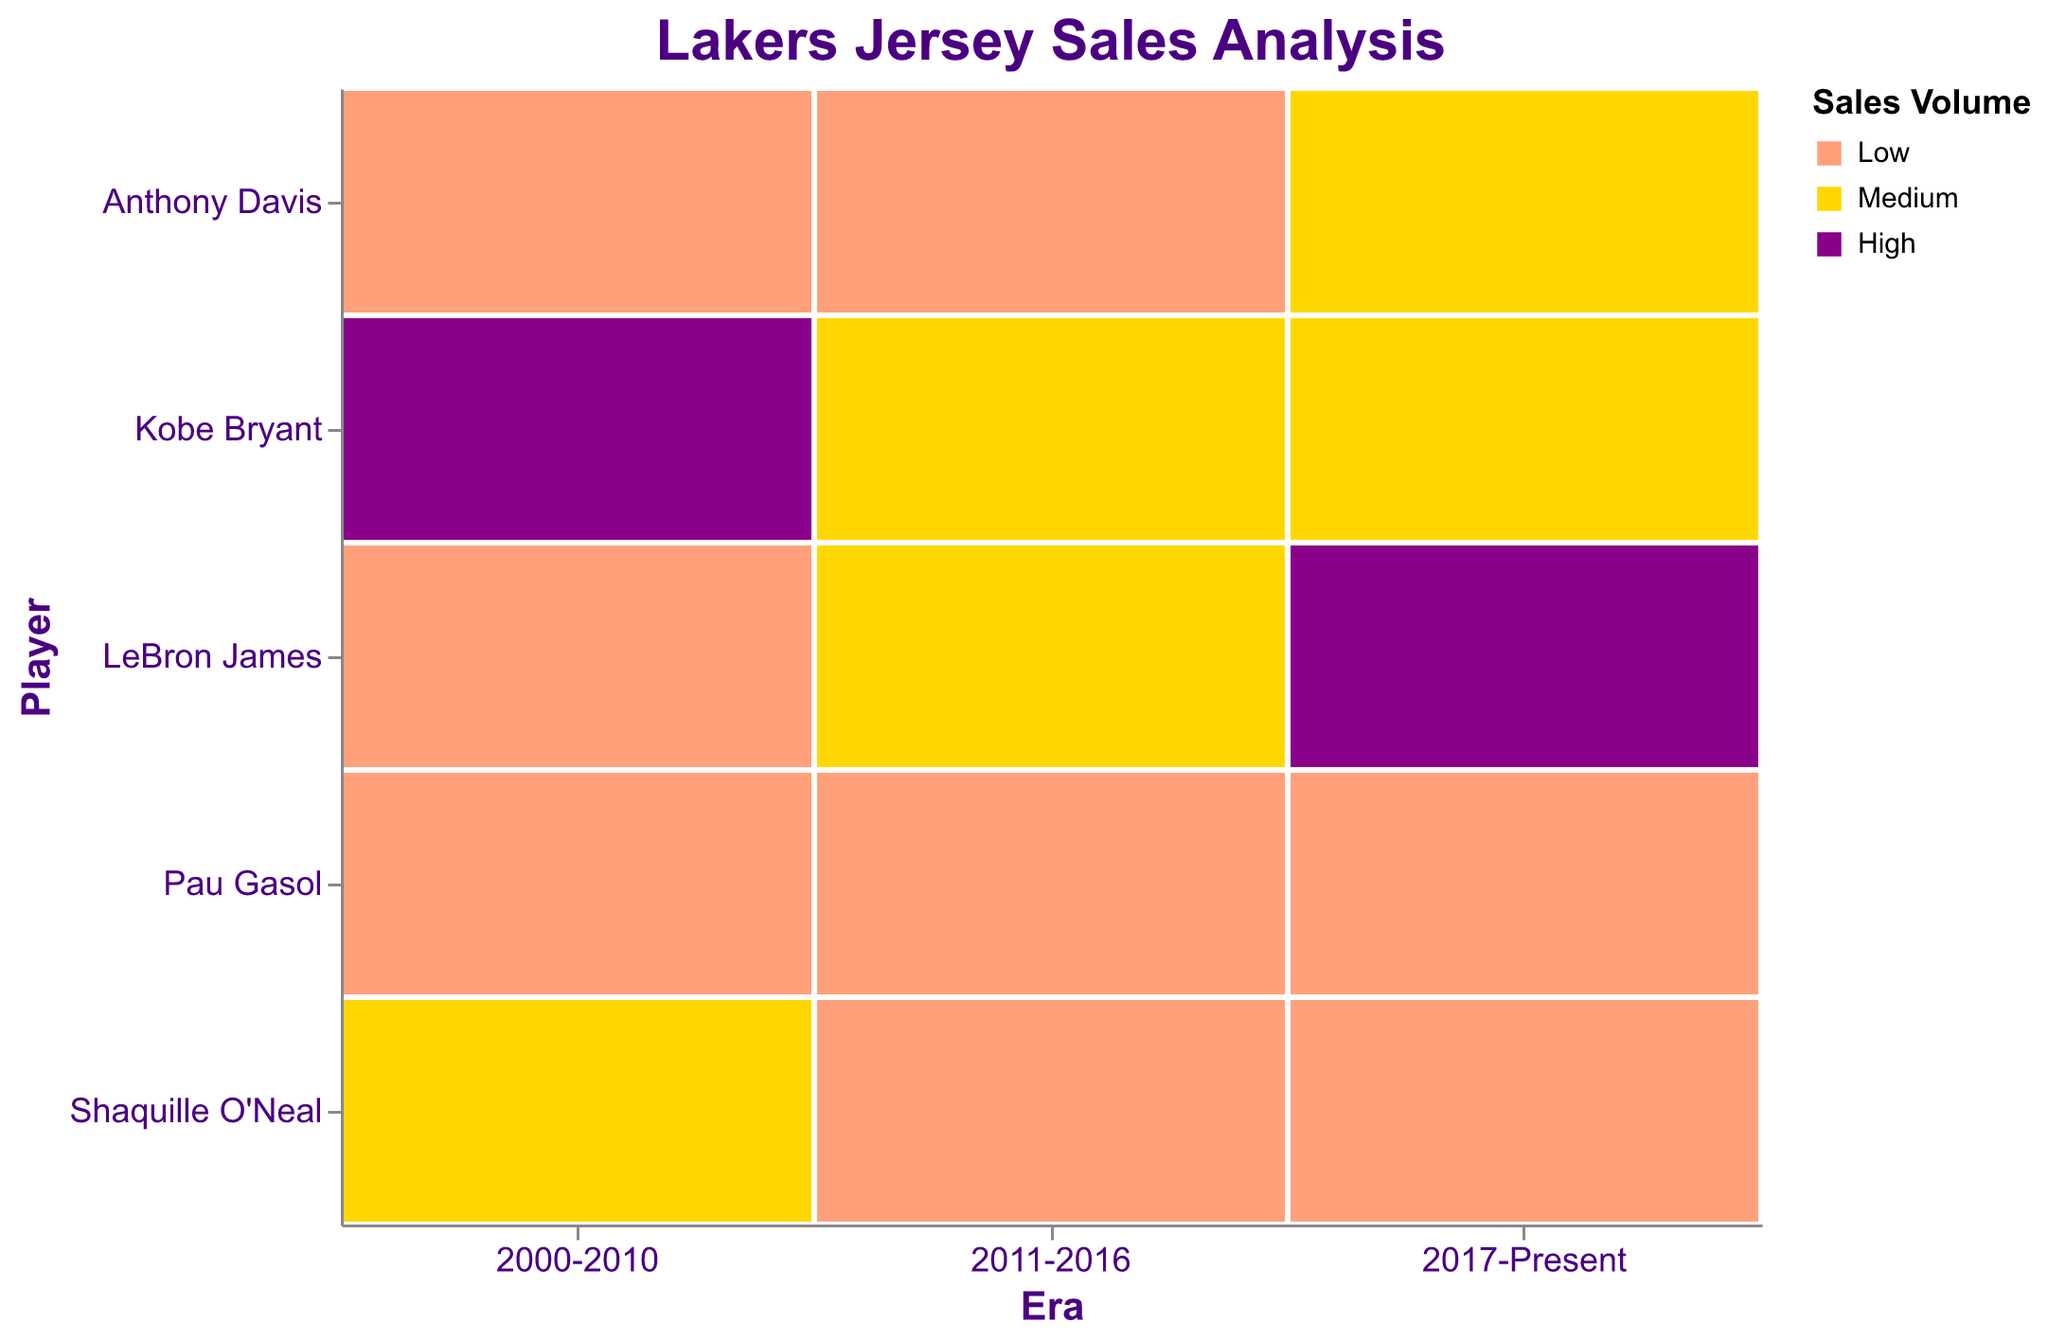What is the title of the figure? The title of the figure is displayed at the top in larger font. It reads "Lakers Jersey Sales Analysis".
Answer: Lakers Jersey Sales Analysis Which player has a high sales volume in the 2000-2010 era? Inspecting the color blocks in the 2000-2010 column reveals that Kobe Bryant has a 'High' sales volume, marked by a darker purple color.
Answer: Kobe Bryant What are the sales volumes of LeBron James across different eras? By looking at the corresponding rows for LeBron James and the different columns for each era, the colors indicate his sales volumes are 'Low' for 2000-2010, 'Medium' for 2011-2016, and 'High' for 2017-Present.
Answer: Low, Medium, High In which era do Kobe Bryant and LeBron James both have medium sales volumes? By comparing the sales color codings in the row intersections for Kobe Bryant and LeBron James across the eras, both have 'Medium' sales in the 2011-2016 era.
Answer: 2011-2016 Which player has seen the biggest increase in sales volumes from one era to the next? LeBron James had 'Low' sales in 2000-2010 and then 'High' sales in 2017-Present, which is the largest increase (from Low to High). The increase for Kobe Bryant was from Medium to High between two eras, which is smaller than LeBron’s.
Answer: LeBron James What are the total eras where Anthony Davis has 'Low' sales volume? Counting the number of 'Low' sales volume blocks (light orange color) for Anthony Davis across all eras, he has 'Low' sales volume in two eras: 2000-2010 and 2011-2016.
Answer: Two eras Which players have low sales volumes for all eras in which they are included? Observing the row colors for each player, Pau Gasol holds 'Low' sales volumes (light orange) for all three eras: 2000-2010, 2011-2016, and 2017-Present.
Answer: Pau Gasol How does Kobe Bryant's sales volume in 2011-2016 compare to Shaquille O'Neal's sales volume in the same era? In the era of 2011-2016, Kobe Bryant has a 'Medium' sales volume (yellow color), and Shaquille O'Neal has a 'Low' sales volume (light orange color). So, Kobe's sales volume is higher.
Answer: Kobe's sales volume is higher 